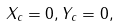<formula> <loc_0><loc_0><loc_500><loc_500>X _ { c } = 0 , Y _ { c } = 0 ,</formula> 